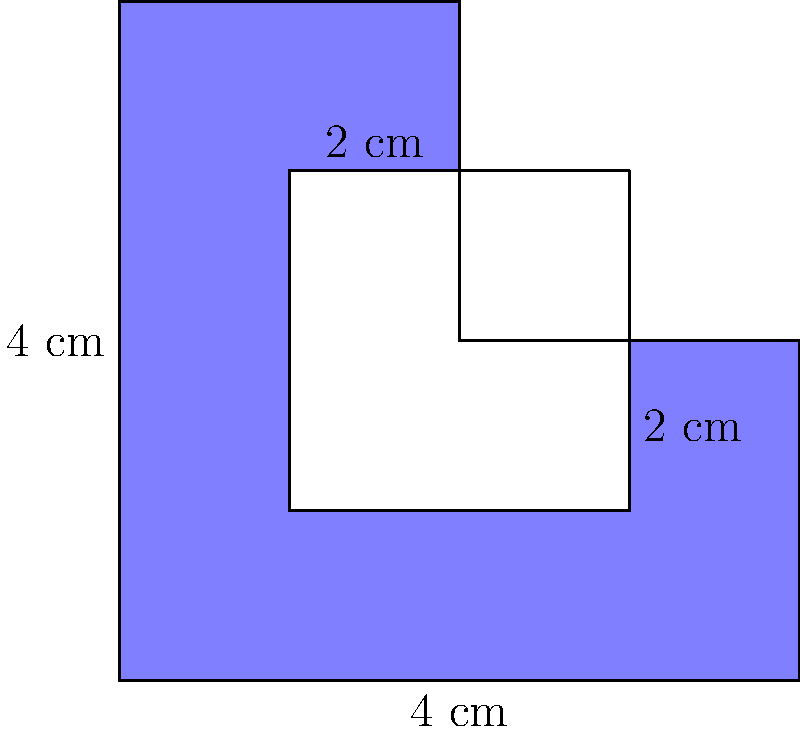As a social media manager, you're working on a new logo design for a brand. The logo is an irregularly shaped blue square with a white square cutout in the center, as shown in the image. The outer square measures 4 cm on each side, while the inner cutout measures 2 cm on each side. Calculate the area of the blue part of the logo in square centimeters. To calculate the area of the blue part of the logo, we need to follow these steps:

1. Calculate the area of the entire outer square:
   $$A_{outer} = 4 \text{ cm} \times 4 \text{ cm} = 16 \text{ cm}^2$$

2. Calculate the area of the inner white cutout:
   $$A_{inner} = 2 \text{ cm} \times 2 \text{ cm} = 4 \text{ cm}^2$$

3. Subtract the area of the inner cutout from the area of the outer square to get the area of the blue part:
   $$A_{blue} = A_{outer} - A_{inner} = 16 \text{ cm}^2 - 4 \text{ cm}^2 = 12 \text{ cm}^2$$

Therefore, the area of the blue part of the logo is 12 square centimeters.
Answer: 12 cm² 